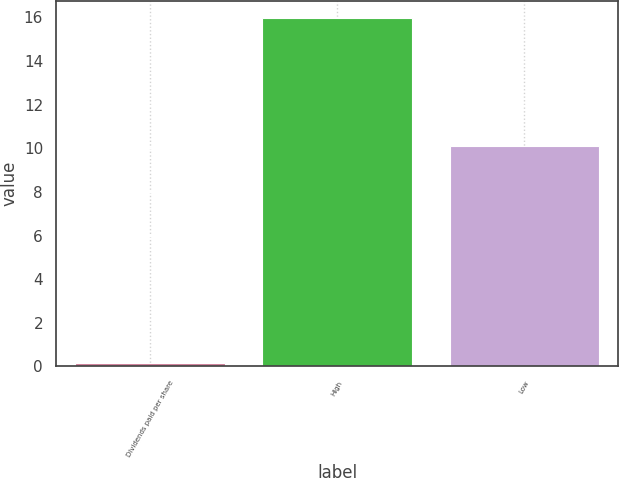<chart> <loc_0><loc_0><loc_500><loc_500><bar_chart><fcel>Dividends paid per share<fcel>High<fcel>Low<nl><fcel>0.15<fcel>15.97<fcel>10.13<nl></chart> 